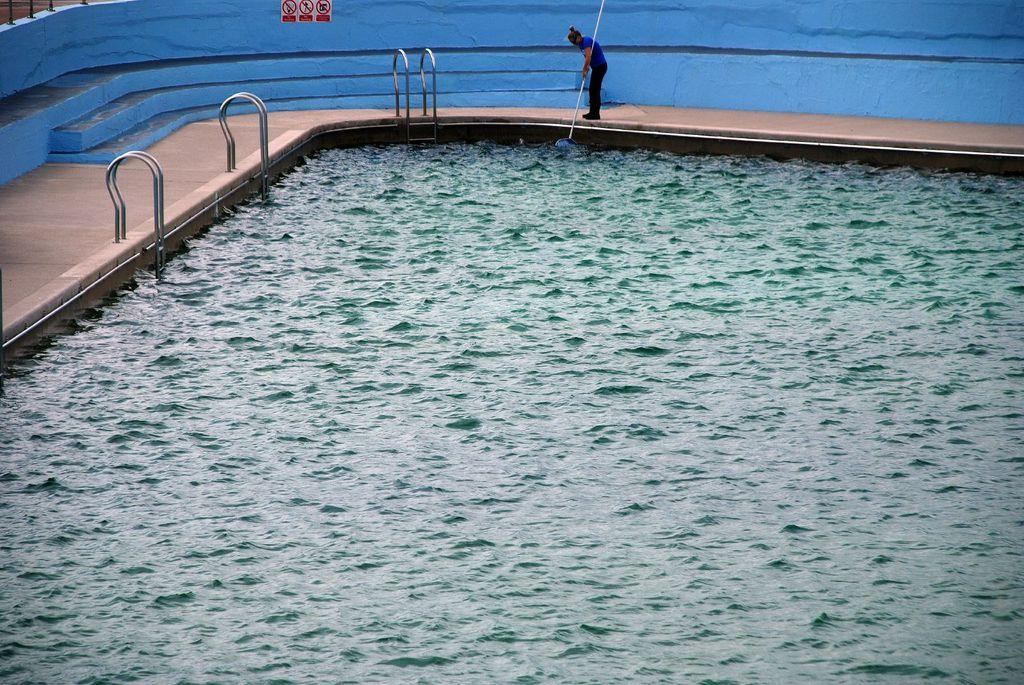What is the main feature of the image? There is a swimming pool in the image. Can you describe the person in the image? There is a person standing in the image, and they are holding an object. What can be seen in the background of the image? There is a wall in the background of the image. Is there is any text or information displayed on the wall? Yes, there is a signboard on the wall. How does the person's feeling of happiness increase while swimming in the pool? The image does not show the person swimming or expressing any emotions, so it is not possible to determine how their feeling of happiness might increase. 